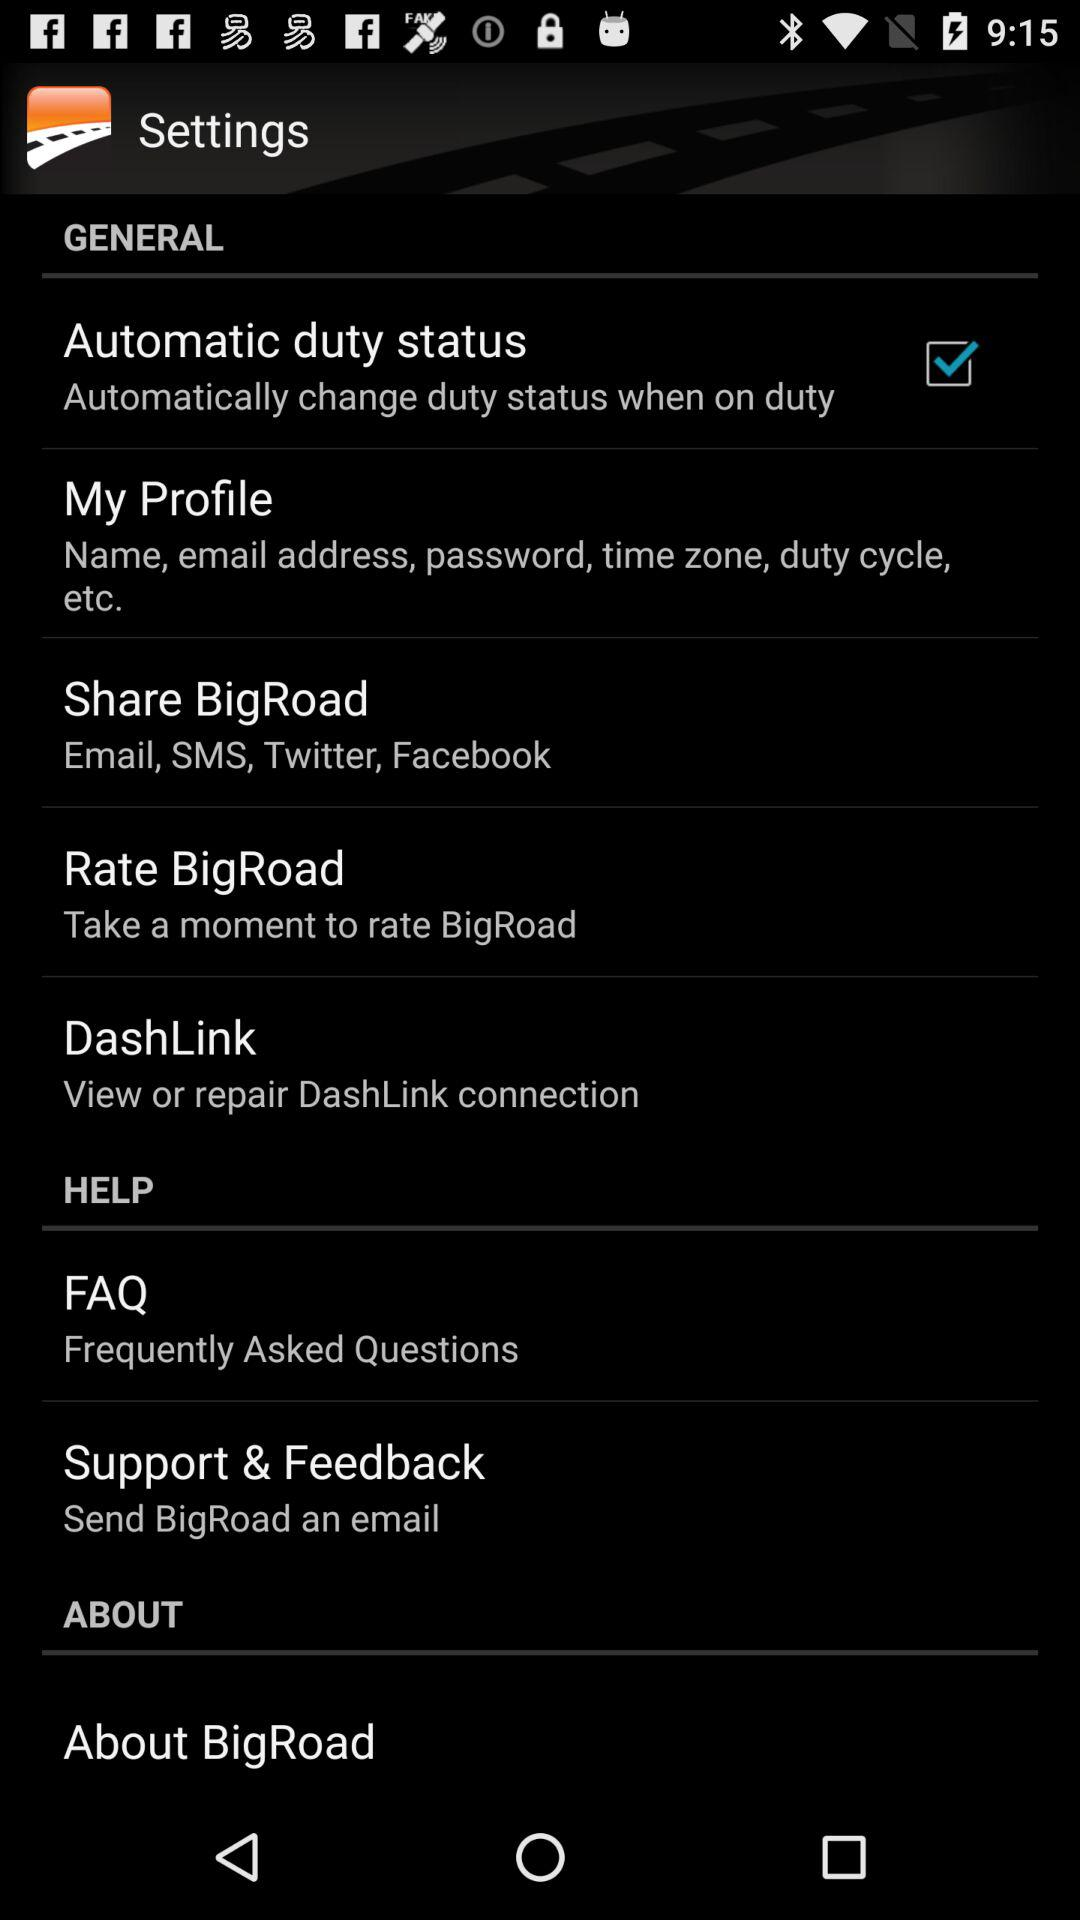What is the checked option? The checked option is "Automatic duty status". 